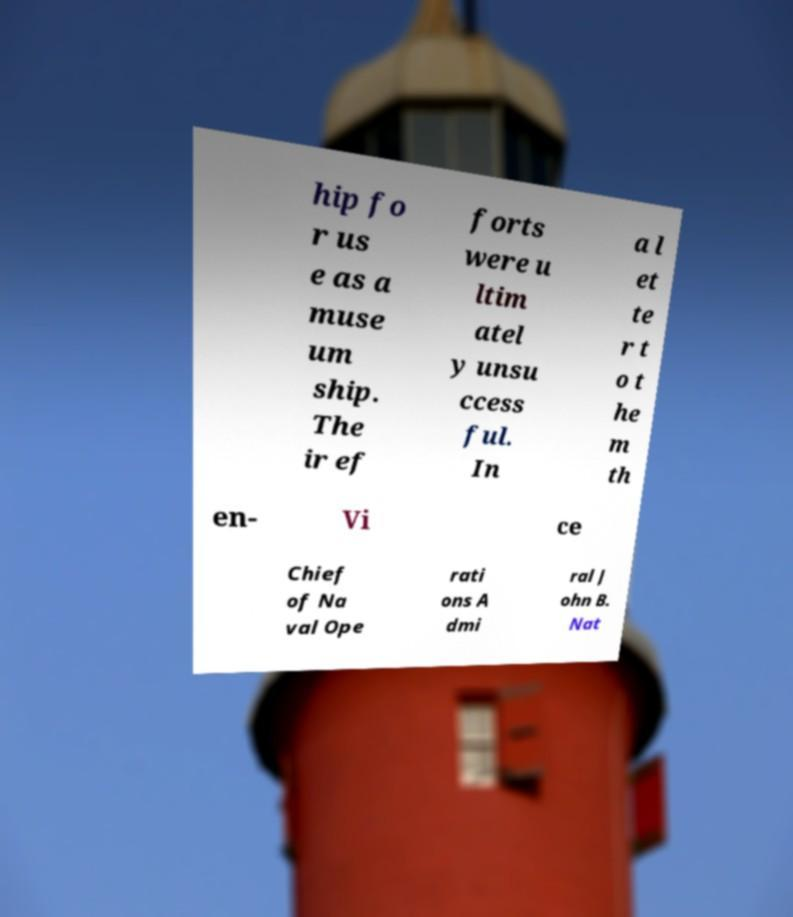For documentation purposes, I need the text within this image transcribed. Could you provide that? hip fo r us e as a muse um ship. The ir ef forts were u ltim atel y unsu ccess ful. In a l et te r t o t he m th en- Vi ce Chief of Na val Ope rati ons A dmi ral J ohn B. Nat 